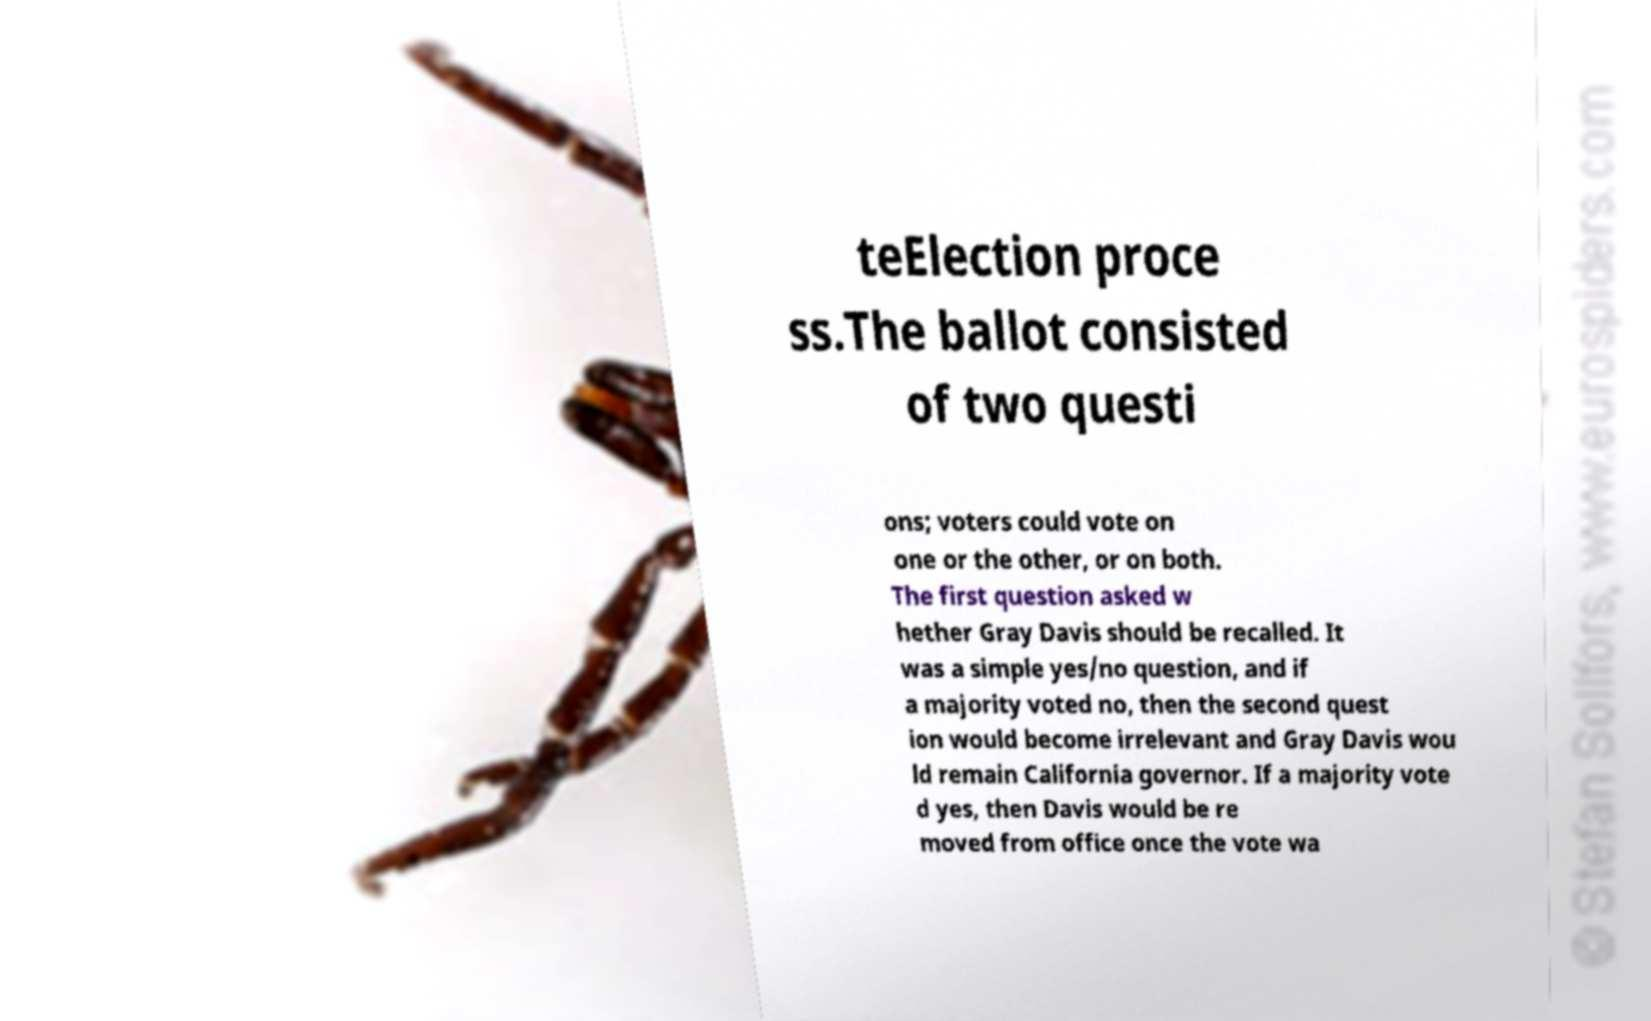Could you extract and type out the text from this image? teElection proce ss.The ballot consisted of two questi ons; voters could vote on one or the other, or on both. The first question asked w hether Gray Davis should be recalled. It was a simple yes/no question, and if a majority voted no, then the second quest ion would become irrelevant and Gray Davis wou ld remain California governor. If a majority vote d yes, then Davis would be re moved from office once the vote wa 